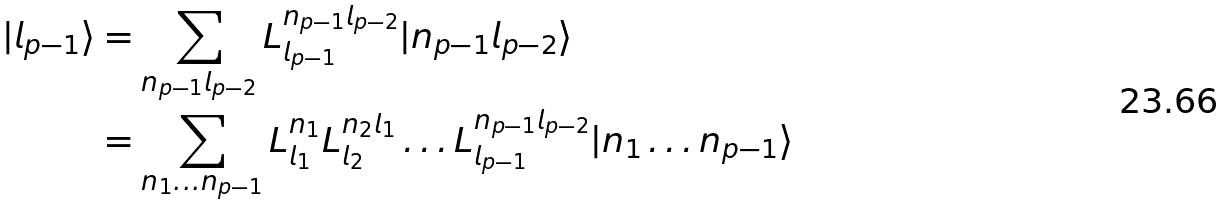Convert formula to latex. <formula><loc_0><loc_0><loc_500><loc_500>| l _ { p - 1 } \rangle & = \sum _ { n _ { p - 1 } l _ { p - 2 } } L ^ { n _ { p - 1 } l _ { p - 2 } } _ { l _ { p - 1 } } | n _ { p - 1 } l _ { p - 2 } \rangle \\ & = \sum _ { n _ { 1 } \dots n _ { p - 1 } } L ^ { n _ { 1 } } _ { l _ { 1 } } L ^ { n _ { 2 } l _ { 1 } } _ { l _ { 2 } } \dots L ^ { n _ { p - 1 } l _ { p - 2 } } _ { l _ { p - 1 } } | n _ { 1 } \dots n _ { p - 1 } \rangle</formula> 